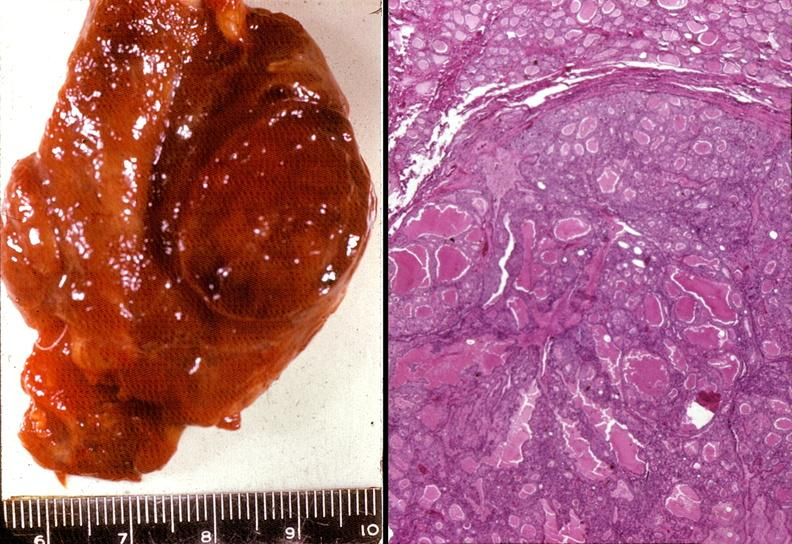what is present?
Answer the question using a single word or phrase. Endocrine 